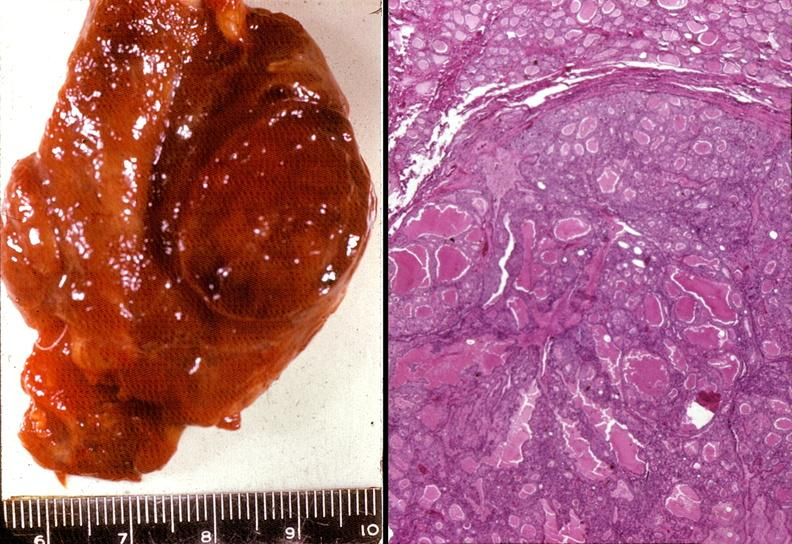what is present?
Answer the question using a single word or phrase. Endocrine 